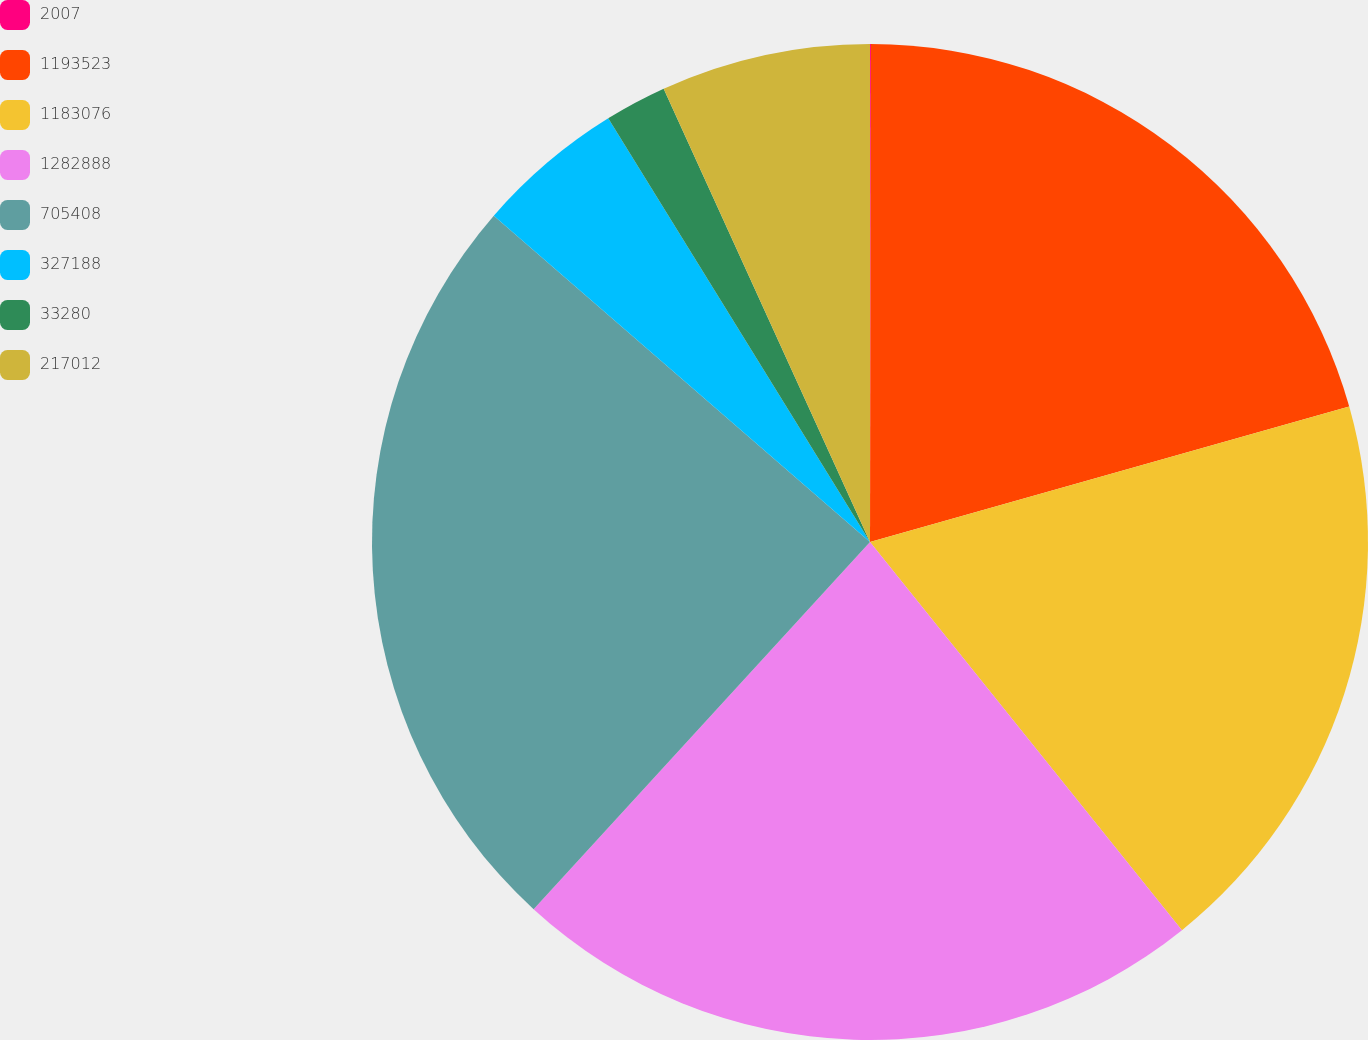Convert chart. <chart><loc_0><loc_0><loc_500><loc_500><pie_chart><fcel>2007<fcel>1193523<fcel>1183076<fcel>1282888<fcel>705408<fcel>327188<fcel>33280<fcel>217012<nl><fcel>0.03%<fcel>20.59%<fcel>18.61%<fcel>22.58%<fcel>24.57%<fcel>4.82%<fcel>2.01%<fcel>6.8%<nl></chart> 